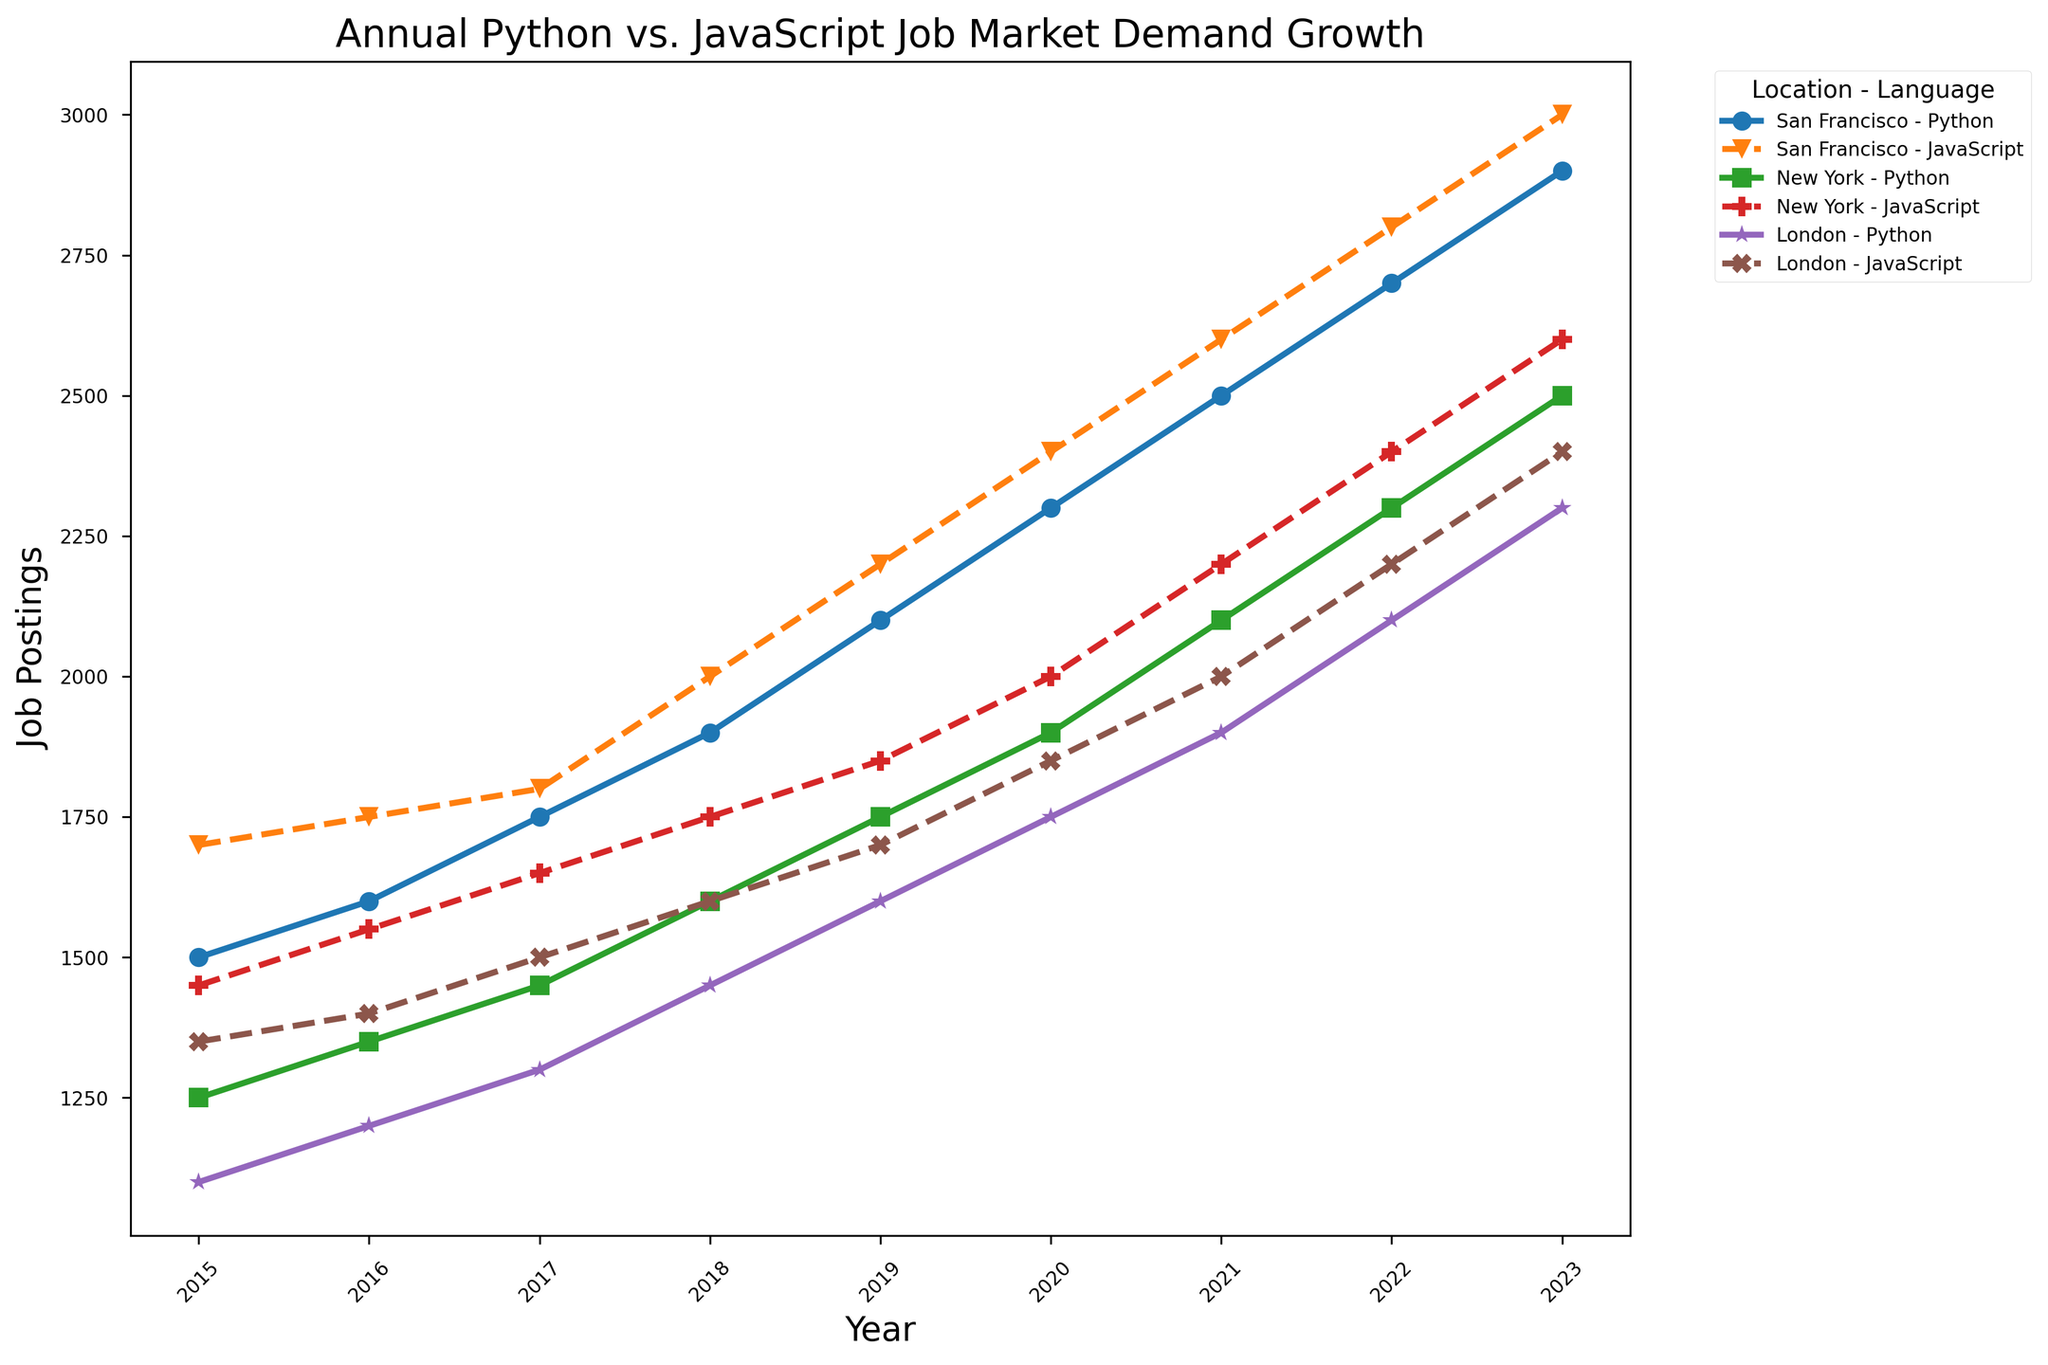Which location shows the highest number of Python job postings in 2023? Look for the Python data points for each location in 2023, and compare their heights on the Y-axis. San Francisco has the highest point.
Answer: San Francisco How did the job postings for JavaScript in New York change from 2020 to 2023? Compare the height of the JavaScript data points for New York in 2020 and 2023. In 2020, it is at 2000, and in 2023, it is at 2600, so it increased by 600.
Answer: Increased by 600 Which year saw the most significant increase in Python job postings in London? Look at the Python data points for London across the years and find the pair of consecutive years with the largest vertical distance between points. The largest increase is between 2021 (1900) and 2022 (2100).
Answer: 2021 to 2022 Comparing San Francisco and London, in which year did they have an equal number of Python job postings? Check the Python data points for San Francisco and London across all years, looking for when their heights are equal. In 2015, both cities had 1500 job postings.
Answer: 2015 What's the percentage increase in job postings for Python in San Francisco from 2015 to 2023? Determine the job postings for Python in San Francisco in 2015 (1500) and 2023 (2900). The increase is 2900 - 1500 = 1400. Calculate the percentage increase: (1400/1500) * 100 = 93.33%.
Answer: 93.33% By how much did the job postings for JavaScript in London increase from 2015 to 2023? Compare the JavaScript job postings in London between 2015 (1350) and 2023 (2400). The increase is 2400 - 1350 = 1050.
Answer: 1050 Which language had a higher growth rate in job postings from 2015 to 2023 in New York? Calculate the growth for both Python (2500 - 1250 = 1250) and JavaScript (2600 - 1450 = 1150) in New York. Compare the differences. Python had a higher growth.
Answer: Python In which year did San Francisco have the same number of job postings for both Python and JavaScript? Compare the Python and JavaScript data points for San Francisco across all years, looking for when their heights are equal. In 2023, both had 2900 job postings.
Answer: 2023 Considering all locations, which year saw the smallest gap between Python and JavaScript job postings? Calculate the gap between Python and JavaScript job postings for each location and year, and determine which year has the smallest differences overall. The smallest gap occurred in 2015 in New York (200).
Answer: 2015, New York Which city had the most stable job growth for Python from 2015 to 2023? Examine the trend lines for Python across all cities from 2015 to 2023. The city with the smallest variability and steady increase is London.
Answer: London 